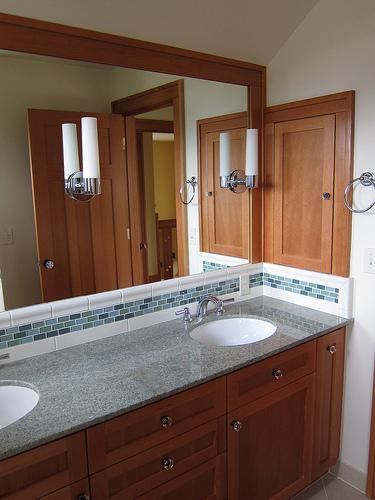Explain the lighting features in the bathroom. There are two vanity mirror lights and two wall sconces mounted on a mirror for illuminating the bathroom. What are the primary decorative elements of this bathroom? A large frame mirror mounted on a wall, two wall sconces mounted on a mirror, and a tiled backsplash above the sink counter.  Identify the main elements of the bathroom's mirror and reflection. A large frame mirror mounted on a wall shows the reflection of an open door, a light, and a doorway. What are some storage features in the bathroom? A brown cabinet under the sink and a towel cabinet on the wall offer storage space in the bathroom. Describe the appearance and features of the sinks and faucet. The sinks are white undermount with recessed bathroom sink basins on a grey marble countertop. The faucet next to the sink is silver-colored with a chrome handle. Mention two features about the bathroom's electric components. The bathroom has an electric outlet in the sink area and vanity mirror lights for illumination. Describe the state of the door in the bathroom and its reflection. The door of the bathroom is open, and its reflection can be seen in the mirror mounted on the wall. What are the colors of the countertop and cabinet in the bathroom? The countertop is grey marble while the cabinet has a brown door. List the key objects in the bathroom. Double sinks, wall sconces, large mirror, towel ring, marble countertop, undermount sink, backsplash, glass knobs, slanted ceiling, recessed bathroom sink basin, chrome faucet, vanity mirror light, brown cabinet door, chrome towel hanger. 